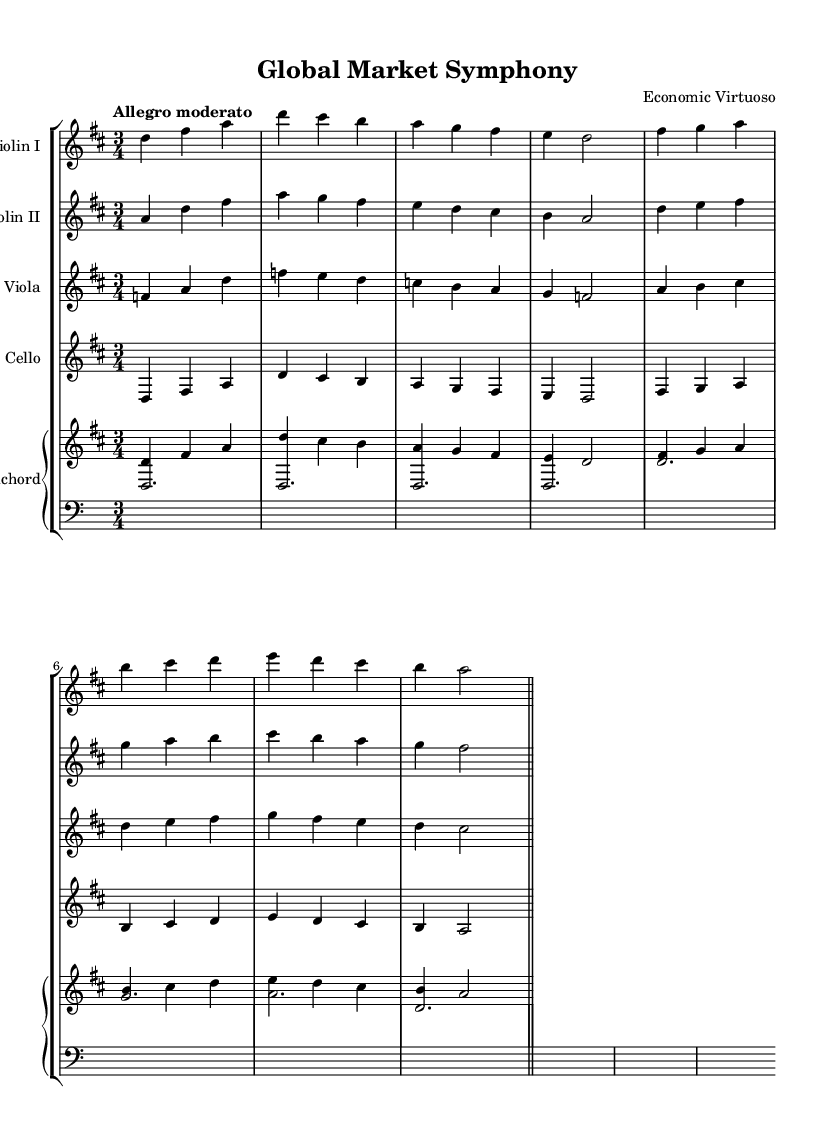What is the key signature of this music? The key signature is D major, indicated by two sharps (F# and C#) in the signature line at the beginning of the staff.
Answer: D major What is the time signature of this music? The time signature is 3/4, which means there are three beats in each measure and the quarter note gets one beat, as shown at the beginning of the score.
Answer: 3/4 What is the tempo marking for this piece? The tempo marking is "Allegro moderato", which indicates a moderately fast tempo, stated above the staff at the beginning of the score.
Answer: Allegro moderato Which instruments are involved in this chamber music composition? The instruments listed are Violin I, Violin II, Viola, Cello, and Harpsichord, as identified at the start of each staff.
Answer: Violin I, Violin II, Viola, Cello, Harpsichord How many measures are in the piece? The score consists of multiple measures, and to count them, we observe the repeated bar lines, with two measures present before each double bar in the score. Counting all indicated measures shows there are a total of 16 measures in this piece before the end.
Answer: 16 What compositional technique is prominent in this music? A prominent compositional technique in this Baroque chamber music is contrapuntal writing, where different melodic lines are interwoven, evident as each instrument has distinct, independently moving lines that interact harmoniously.
Answer: Counterpoint What do the performers follow for dynamic cues? The performers follow the score for dynamic cues as dynamic markings can be indicated notationally, usually placed underneath or above the notation, however, in this excerpt, specific dynamics may not be explicitly noted.
Answer: The score 